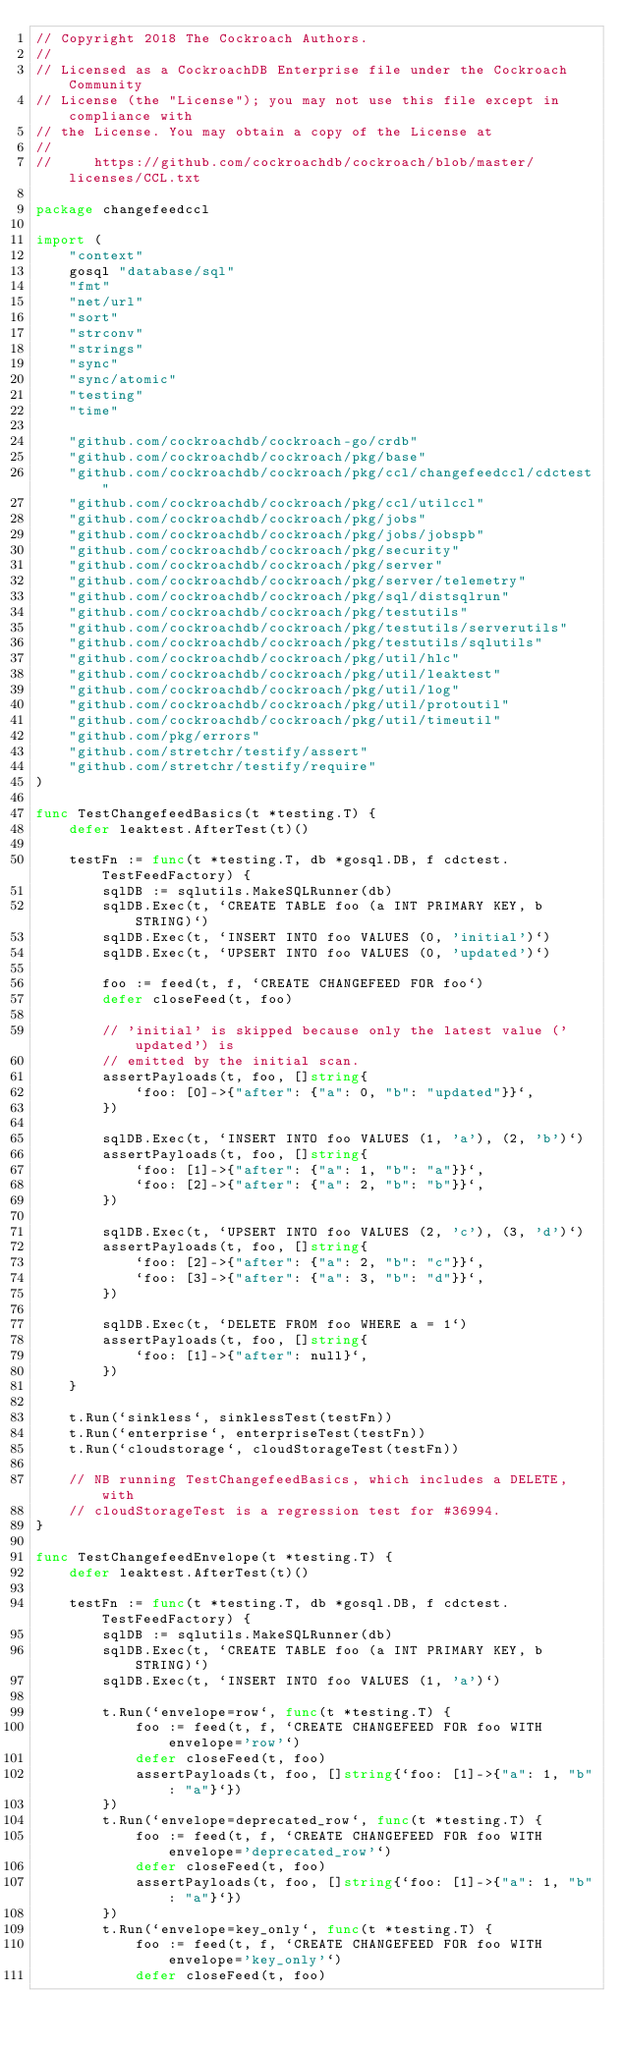Convert code to text. <code><loc_0><loc_0><loc_500><loc_500><_Go_>// Copyright 2018 The Cockroach Authors.
//
// Licensed as a CockroachDB Enterprise file under the Cockroach Community
// License (the "License"); you may not use this file except in compliance with
// the License. You may obtain a copy of the License at
//
//     https://github.com/cockroachdb/cockroach/blob/master/licenses/CCL.txt

package changefeedccl

import (
	"context"
	gosql "database/sql"
	"fmt"
	"net/url"
	"sort"
	"strconv"
	"strings"
	"sync"
	"sync/atomic"
	"testing"
	"time"

	"github.com/cockroachdb/cockroach-go/crdb"
	"github.com/cockroachdb/cockroach/pkg/base"
	"github.com/cockroachdb/cockroach/pkg/ccl/changefeedccl/cdctest"
	"github.com/cockroachdb/cockroach/pkg/ccl/utilccl"
	"github.com/cockroachdb/cockroach/pkg/jobs"
	"github.com/cockroachdb/cockroach/pkg/jobs/jobspb"
	"github.com/cockroachdb/cockroach/pkg/security"
	"github.com/cockroachdb/cockroach/pkg/server"
	"github.com/cockroachdb/cockroach/pkg/server/telemetry"
	"github.com/cockroachdb/cockroach/pkg/sql/distsqlrun"
	"github.com/cockroachdb/cockroach/pkg/testutils"
	"github.com/cockroachdb/cockroach/pkg/testutils/serverutils"
	"github.com/cockroachdb/cockroach/pkg/testutils/sqlutils"
	"github.com/cockroachdb/cockroach/pkg/util/hlc"
	"github.com/cockroachdb/cockroach/pkg/util/leaktest"
	"github.com/cockroachdb/cockroach/pkg/util/log"
	"github.com/cockroachdb/cockroach/pkg/util/protoutil"
	"github.com/cockroachdb/cockroach/pkg/util/timeutil"
	"github.com/pkg/errors"
	"github.com/stretchr/testify/assert"
	"github.com/stretchr/testify/require"
)

func TestChangefeedBasics(t *testing.T) {
	defer leaktest.AfterTest(t)()

	testFn := func(t *testing.T, db *gosql.DB, f cdctest.TestFeedFactory) {
		sqlDB := sqlutils.MakeSQLRunner(db)
		sqlDB.Exec(t, `CREATE TABLE foo (a INT PRIMARY KEY, b STRING)`)
		sqlDB.Exec(t, `INSERT INTO foo VALUES (0, 'initial')`)
		sqlDB.Exec(t, `UPSERT INTO foo VALUES (0, 'updated')`)

		foo := feed(t, f, `CREATE CHANGEFEED FOR foo`)
		defer closeFeed(t, foo)

		// 'initial' is skipped because only the latest value ('updated') is
		// emitted by the initial scan.
		assertPayloads(t, foo, []string{
			`foo: [0]->{"after": {"a": 0, "b": "updated"}}`,
		})

		sqlDB.Exec(t, `INSERT INTO foo VALUES (1, 'a'), (2, 'b')`)
		assertPayloads(t, foo, []string{
			`foo: [1]->{"after": {"a": 1, "b": "a"}}`,
			`foo: [2]->{"after": {"a": 2, "b": "b"}}`,
		})

		sqlDB.Exec(t, `UPSERT INTO foo VALUES (2, 'c'), (3, 'd')`)
		assertPayloads(t, foo, []string{
			`foo: [2]->{"after": {"a": 2, "b": "c"}}`,
			`foo: [3]->{"after": {"a": 3, "b": "d"}}`,
		})

		sqlDB.Exec(t, `DELETE FROM foo WHERE a = 1`)
		assertPayloads(t, foo, []string{
			`foo: [1]->{"after": null}`,
		})
	}

	t.Run(`sinkless`, sinklessTest(testFn))
	t.Run(`enterprise`, enterpriseTest(testFn))
	t.Run(`cloudstorage`, cloudStorageTest(testFn))

	// NB running TestChangefeedBasics, which includes a DELETE, with
	// cloudStorageTest is a regression test for #36994.
}

func TestChangefeedEnvelope(t *testing.T) {
	defer leaktest.AfterTest(t)()

	testFn := func(t *testing.T, db *gosql.DB, f cdctest.TestFeedFactory) {
		sqlDB := sqlutils.MakeSQLRunner(db)
		sqlDB.Exec(t, `CREATE TABLE foo (a INT PRIMARY KEY, b STRING)`)
		sqlDB.Exec(t, `INSERT INTO foo VALUES (1, 'a')`)

		t.Run(`envelope=row`, func(t *testing.T) {
			foo := feed(t, f, `CREATE CHANGEFEED FOR foo WITH envelope='row'`)
			defer closeFeed(t, foo)
			assertPayloads(t, foo, []string{`foo: [1]->{"a": 1, "b": "a"}`})
		})
		t.Run(`envelope=deprecated_row`, func(t *testing.T) {
			foo := feed(t, f, `CREATE CHANGEFEED FOR foo WITH envelope='deprecated_row'`)
			defer closeFeed(t, foo)
			assertPayloads(t, foo, []string{`foo: [1]->{"a": 1, "b": "a"}`})
		})
		t.Run(`envelope=key_only`, func(t *testing.T) {
			foo := feed(t, f, `CREATE CHANGEFEED FOR foo WITH envelope='key_only'`)
			defer closeFeed(t, foo)</code> 